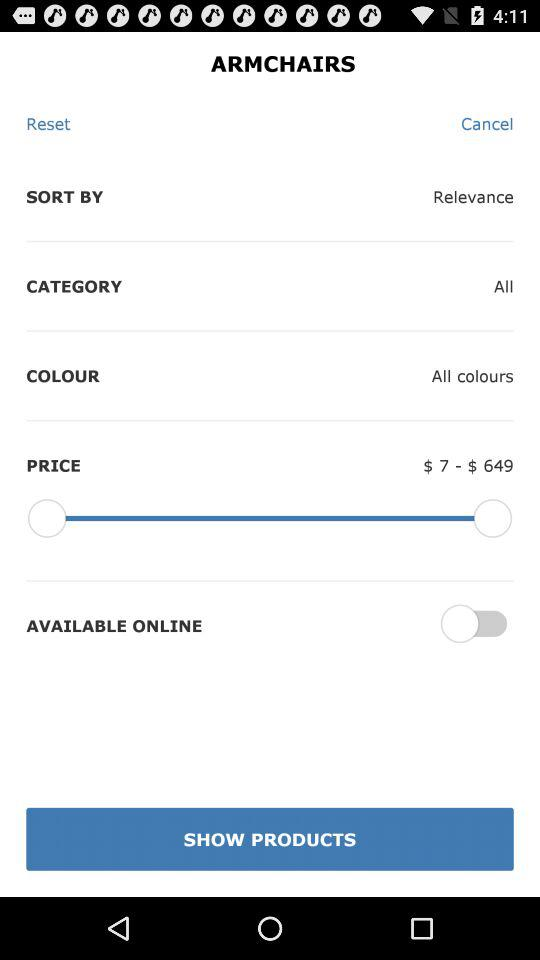What is the difference in price between the most expensive and least expensive armchairs?
Answer the question using a single word or phrase. $642 